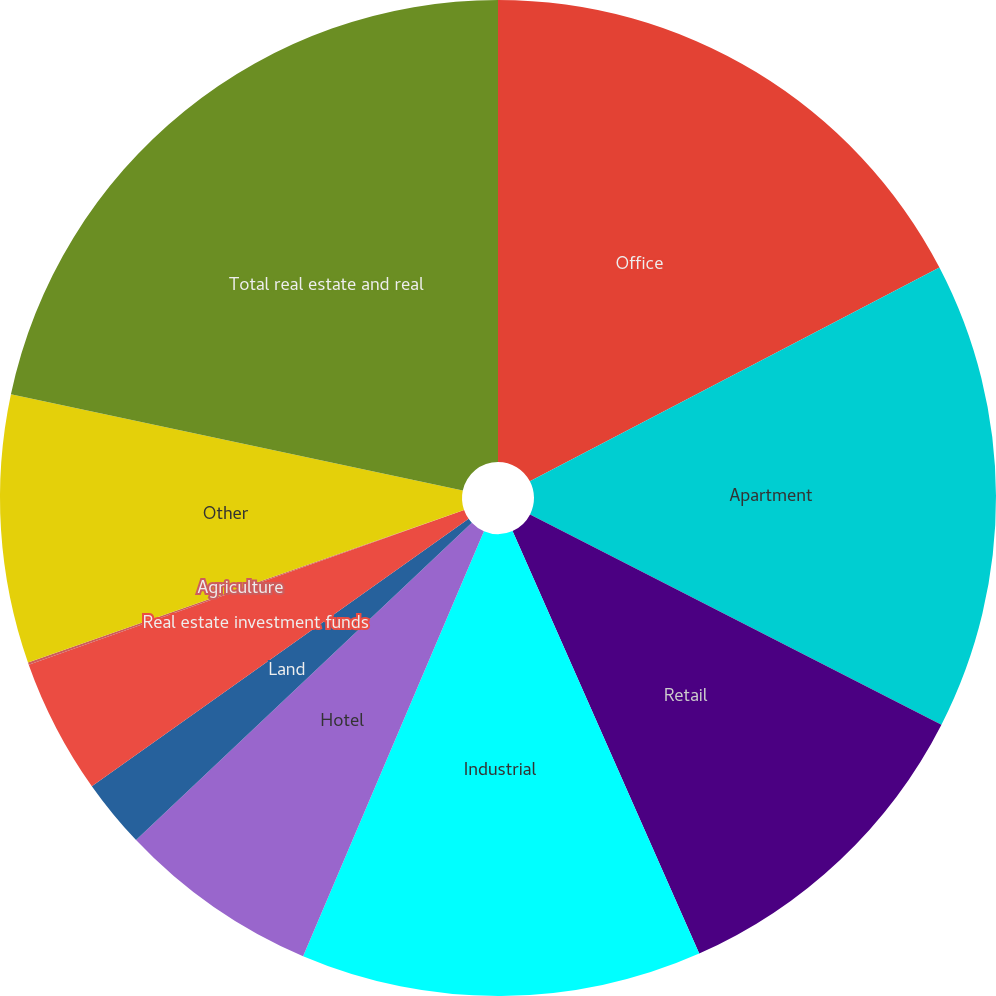Convert chart. <chart><loc_0><loc_0><loc_500><loc_500><pie_chart><fcel>Office<fcel>Apartment<fcel>Retail<fcel>Industrial<fcel>Hotel<fcel>Land<fcel>Real estate investment funds<fcel>Agriculture<fcel>Other<fcel>Total real estate and real<nl><fcel>17.34%<fcel>15.18%<fcel>10.86%<fcel>13.02%<fcel>6.55%<fcel>2.23%<fcel>4.39%<fcel>0.07%<fcel>8.7%<fcel>21.66%<nl></chart> 